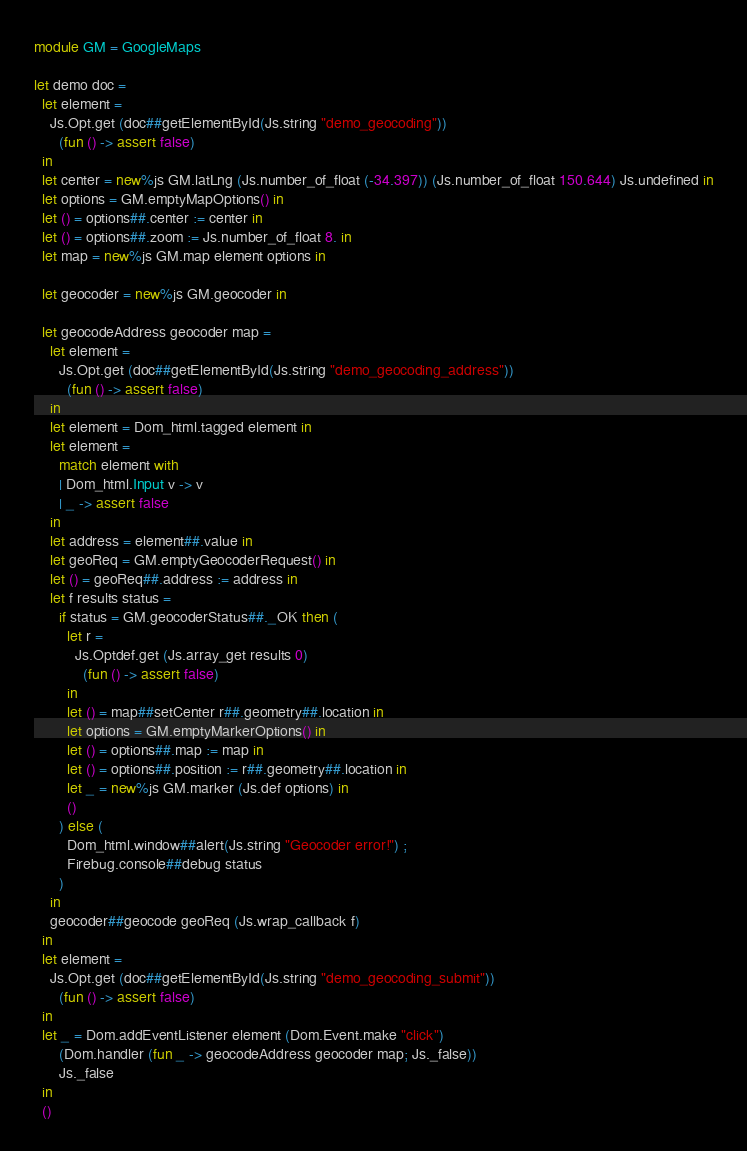Convert code to text. <code><loc_0><loc_0><loc_500><loc_500><_OCaml_>module GM = GoogleMaps

let demo doc =
  let element =
    Js.Opt.get (doc##getElementById(Js.string "demo_geocoding"))
      (fun () -> assert false)
  in
  let center = new%js GM.latLng (Js.number_of_float (-34.397)) (Js.number_of_float 150.644) Js.undefined in
  let options = GM.emptyMapOptions() in
  let () = options##.center := center in
  let () = options##.zoom := Js.number_of_float 8. in
  let map = new%js GM.map element options in

  let geocoder = new%js GM.geocoder in

  let geocodeAddress geocoder map =
    let element =
      Js.Opt.get (doc##getElementById(Js.string "demo_geocoding_address"))
        (fun () -> assert false)
    in
    let element = Dom_html.tagged element in
    let element =
      match element with
      | Dom_html.Input v -> v
      | _ -> assert false
    in
    let address = element##.value in
    let geoReq = GM.emptyGeocoderRequest() in
    let () = geoReq##.address := address in
    let f results status =
      if status = GM.geocoderStatus##._OK then (
        let r =
          Js.Optdef.get (Js.array_get results 0)
            (fun () -> assert false)
        in
        let () = map##setCenter r##.geometry##.location in
        let options = GM.emptyMarkerOptions() in
        let () = options##.map := map in
        let () = options##.position := r##.geometry##.location in
        let _ = new%js GM.marker (Js.def options) in
        ()
      ) else (
        Dom_html.window##alert(Js.string "Geocoder error!") ;
        Firebug.console##debug status
      )
    in
    geocoder##geocode geoReq (Js.wrap_callback f)
  in
  let element =
    Js.Opt.get (doc##getElementById(Js.string "demo_geocoding_submit"))
      (fun () -> assert false)
  in
  let _ = Dom.addEventListener element (Dom.Event.make "click")
      (Dom.handler (fun _ -> geocodeAddress geocoder map; Js._false))
      Js._false
  in
  ()</code> 